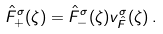<formula> <loc_0><loc_0><loc_500><loc_500>\hat { F } ^ { \sigma } _ { + } ( \zeta ) = \hat { F } ^ { \sigma } _ { - } ( \zeta ) { v } _ { \hat { F } } ^ { \sigma } ( \zeta ) \, .</formula> 